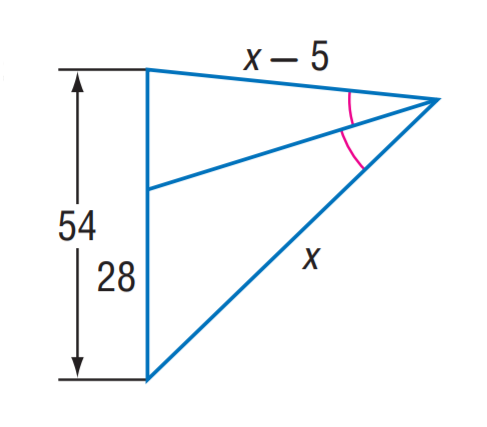Question: Find x.
Choices:
A. 42
B. 56
C. 70
D. 84
Answer with the letter. Answer: C 